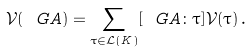<formula> <loc_0><loc_0><loc_500><loc_500>\mathcal { V } ( \ G A ) = \sum _ { \tau \in \mathcal { L } ( K ) } [ \ G A \colon \tau ] \mathcal { V } ( \tau ) \, .</formula> 